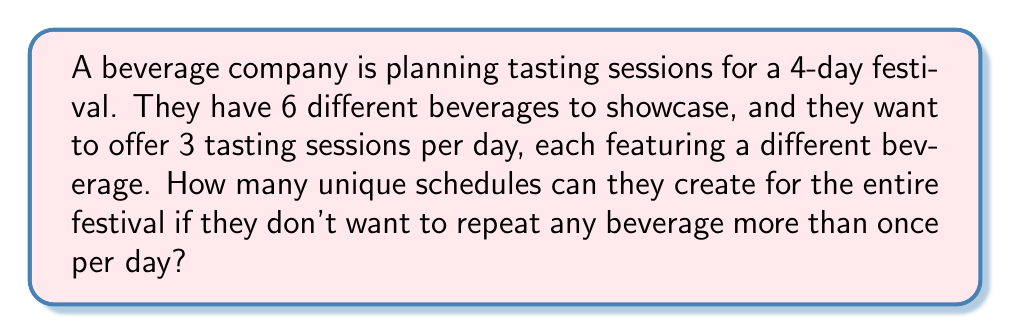Give your solution to this math problem. Let's approach this step-by-step:

1) For each day, we need to choose 3 beverages out of 6 for the tasting sessions. This is a combination problem.

2) The number of ways to choose 3 beverages out of 6 for a single day is:

   $$\binom{6}{3} = \frac{6!}{3!(6-3)!} = \frac{6!}{3!3!} = 20$$

3) However, the order of these 3 beverages within the day matters (as they are for different sessions). So for each combination, we need to consider the permutations of these 3 beverages.

4) The number of permutations of 3 beverages is:

   $$3! = 6$$

5) So, for each day, the number of possible arrangements is:

   $$20 \times 6 = 120$$

6) Now, we need to do this for all 4 days of the festival. Since the selection for each day is independent, we multiply the possibilities:

   $$120^4 = 207,360,000$$

Therefore, there are 207,360,000 unique schedules possible for the entire festival.
Answer: 207,360,000 